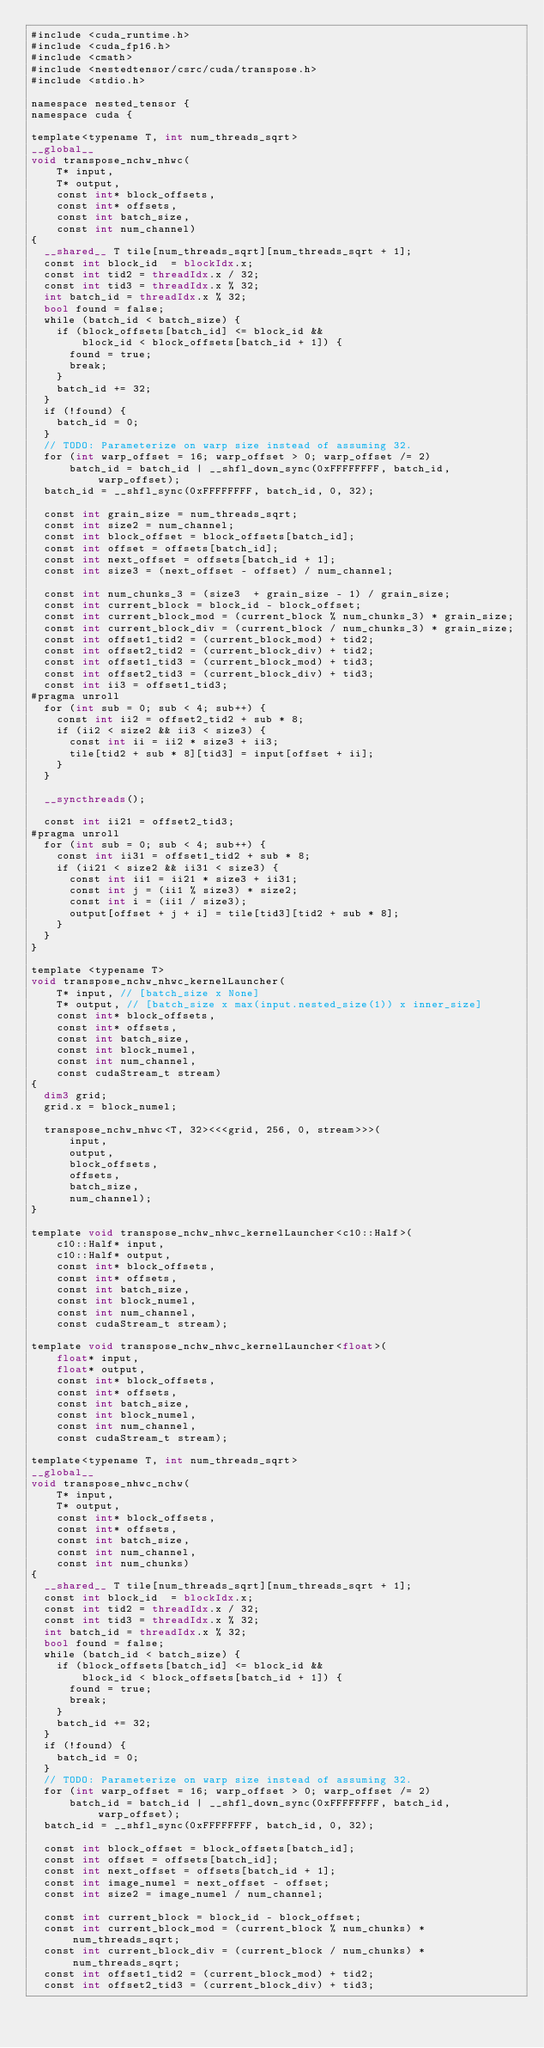<code> <loc_0><loc_0><loc_500><loc_500><_Cuda_>#include <cuda_runtime.h>
#include <cuda_fp16.h>
#include <cmath>
#include <nestedtensor/csrc/cuda/transpose.h>
#include <stdio.h>

namespace nested_tensor {
namespace cuda {

template<typename T, int num_threads_sqrt>
__global__
void transpose_nchw_nhwc(
    T* input,
    T* output,
    const int* block_offsets,
    const int* offsets,
    const int batch_size,
    const int num_channel)
{
  __shared__ T tile[num_threads_sqrt][num_threads_sqrt + 1];
  const int block_id  = blockIdx.x;
  const int tid2 = threadIdx.x / 32;
  const int tid3 = threadIdx.x % 32;
  int batch_id = threadIdx.x % 32;
  bool found = false;
  while (batch_id < batch_size) {
    if (block_offsets[batch_id] <= block_id && 
        block_id < block_offsets[batch_id + 1]) {
      found = true;
      break;
    }
    batch_id += 32;
  }
  if (!found) {
    batch_id = 0;
  }
  // TODO: Parameterize on warp size instead of assuming 32.
  for (int warp_offset = 16; warp_offset > 0; warp_offset /= 2)
      batch_id = batch_id | __shfl_down_sync(0xFFFFFFFF, batch_id, warp_offset);
  batch_id = __shfl_sync(0xFFFFFFFF, batch_id, 0, 32);

  const int grain_size = num_threads_sqrt;
  const int size2 = num_channel;
  const int block_offset = block_offsets[batch_id];
  const int offset = offsets[batch_id];
  const int next_offset = offsets[batch_id + 1];
  const int size3 = (next_offset - offset) / num_channel;

  const int num_chunks_3 = (size3  + grain_size - 1) / grain_size;
  const int current_block = block_id - block_offset;
  const int current_block_mod = (current_block % num_chunks_3) * grain_size;
  const int current_block_div = (current_block / num_chunks_3) * grain_size;
  const int offset1_tid2 = (current_block_mod) + tid2;
  const int offset2_tid2 = (current_block_div) + tid2;
  const int offset1_tid3 = (current_block_mod) + tid3;
  const int offset2_tid3 = (current_block_div) + tid3;
  const int ii3 = offset1_tid3;
#pragma unroll
  for (int sub = 0; sub < 4; sub++) {
    const int ii2 = offset2_tid2 + sub * 8;
    if (ii2 < size2 && ii3 < size3) {
      const int ii = ii2 * size3 + ii3;
      tile[tid2 + sub * 8][tid3] = input[offset + ii];
    }
  }

  __syncthreads();

  const int ii21 = offset2_tid3;
#pragma unroll
  for (int sub = 0; sub < 4; sub++) {
    const int ii31 = offset1_tid2 + sub * 8;
    if (ii21 < size2 && ii31 < size3) {
      const int ii1 = ii21 * size3 + ii31;
      const int j = (ii1 % size3) * size2;
      const int i = (ii1 / size3);
      output[offset + j + i] = tile[tid3][tid2 + sub * 8];
    }
  }
}

template <typename T>
void transpose_nchw_nhwc_kernelLauncher(
    T* input, // [batch_size x None]
    T* output, // [batch_size x max(input.nested_size(1)) x inner_size]
    const int* block_offsets,
    const int* offsets,
    const int batch_size,
    const int block_numel,
    const int num_channel,
    const cudaStream_t stream)
{
  dim3 grid;
  grid.x = block_numel;

  transpose_nchw_nhwc<T, 32><<<grid, 256, 0, stream>>>(
      input,
      output,
      block_offsets,
      offsets,
      batch_size,
      num_channel);
}

template void transpose_nchw_nhwc_kernelLauncher<c10::Half>(
    c10::Half* input,
    c10::Half* output,
    const int* block_offsets,
    const int* offsets,
    const int batch_size,
    const int block_numel,
    const int num_channel,
    const cudaStream_t stream);

template void transpose_nchw_nhwc_kernelLauncher<float>(
    float* input,
    float* output,
    const int* block_offsets,
    const int* offsets,
    const int batch_size,
    const int block_numel,
    const int num_channel,
    const cudaStream_t stream);

template<typename T, int num_threads_sqrt>
__global__
void transpose_nhwc_nchw(
    T* input,
    T* output,
    const int* block_offsets,
    const int* offsets,
    const int batch_size,
    const int num_channel,
    const int num_chunks)
{
  __shared__ T tile[num_threads_sqrt][num_threads_sqrt + 1];
  const int block_id  = blockIdx.x;
  const int tid2 = threadIdx.x / 32;
  const int tid3 = threadIdx.x % 32;
  int batch_id = threadIdx.x % 32;
  bool found = false;
  while (batch_id < batch_size) {
    if (block_offsets[batch_id] <= block_id && 
        block_id < block_offsets[batch_id + 1]) {
      found = true;
      break;
    }
    batch_id += 32;
  }
  if (!found) {
    batch_id = 0;
  }
  // TODO: Parameterize on warp size instead of assuming 32.
  for (int warp_offset = 16; warp_offset > 0; warp_offset /= 2)
      batch_id = batch_id | __shfl_down_sync(0xFFFFFFFF, batch_id, warp_offset);
  batch_id = __shfl_sync(0xFFFFFFFF, batch_id, 0, 32);

  const int block_offset = block_offsets[batch_id];
  const int offset = offsets[batch_id];
  const int next_offset = offsets[batch_id + 1];
  const int image_numel = next_offset - offset;
  const int size2 = image_numel / num_channel;

  const int current_block = block_id - block_offset;
  const int current_block_mod = (current_block % num_chunks) * num_threads_sqrt;
  const int current_block_div = (current_block / num_chunks) * num_threads_sqrt;
  const int offset1_tid2 = (current_block_mod) + tid2;
  const int offset2_tid3 = (current_block_div) + tid3;
</code> 